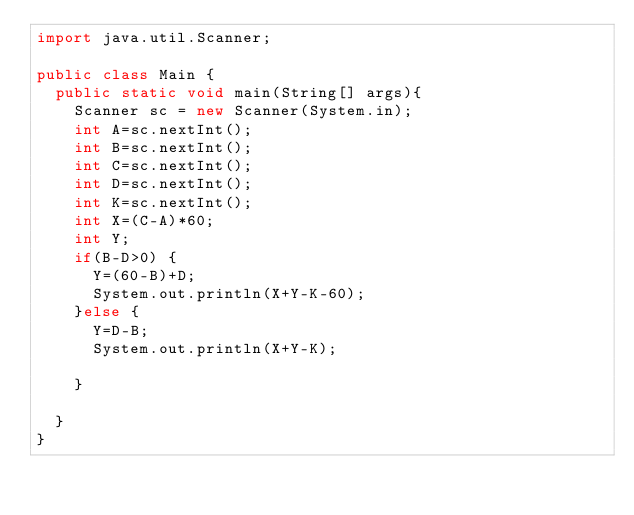<code> <loc_0><loc_0><loc_500><loc_500><_Java_>import java.util.Scanner;

public class Main {
  public static void main(String[] args){
    Scanner sc = new Scanner(System.in);
    int A=sc.nextInt();
    int B=sc.nextInt();
    int C=sc.nextInt();
    int D=sc.nextInt();
    int K=sc.nextInt();
    int X=(C-A)*60;
    int Y;
    if(B-D>0) {
    	Y=(60-B)+D;
    	System.out.println(X+Y-K-60);
    }else {
    	Y=D-B;
    	System.out.println(X+Y-K);
    	
    }

  }
}</code> 